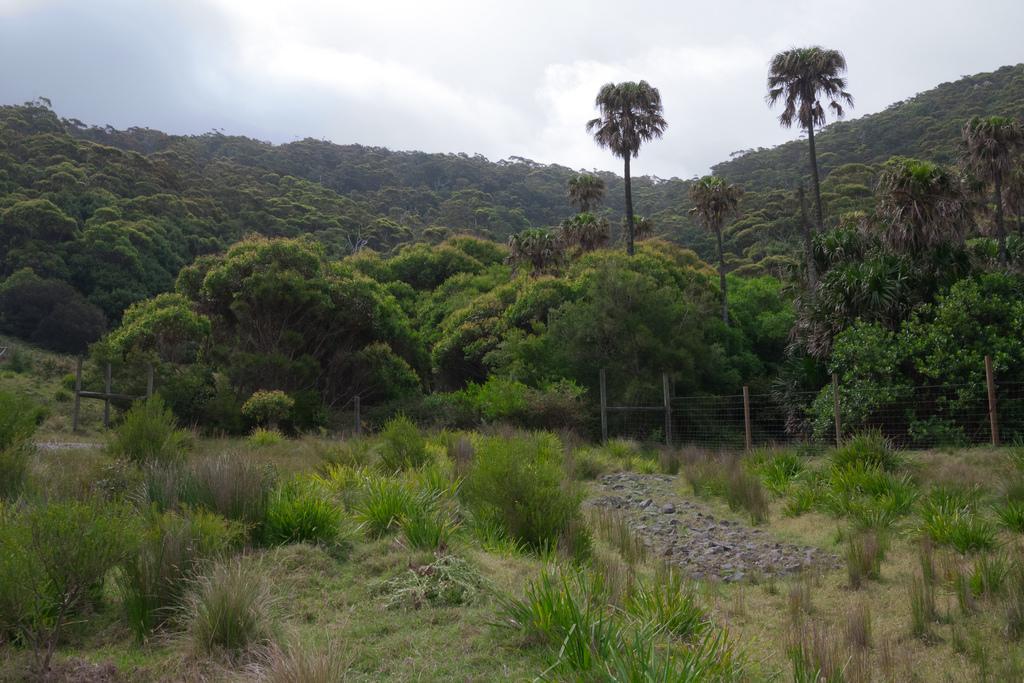Please provide a concise description of this image. In this image, we can see some trees which are green in color. We can also see grass and plants, stones. We can also see the sky. 